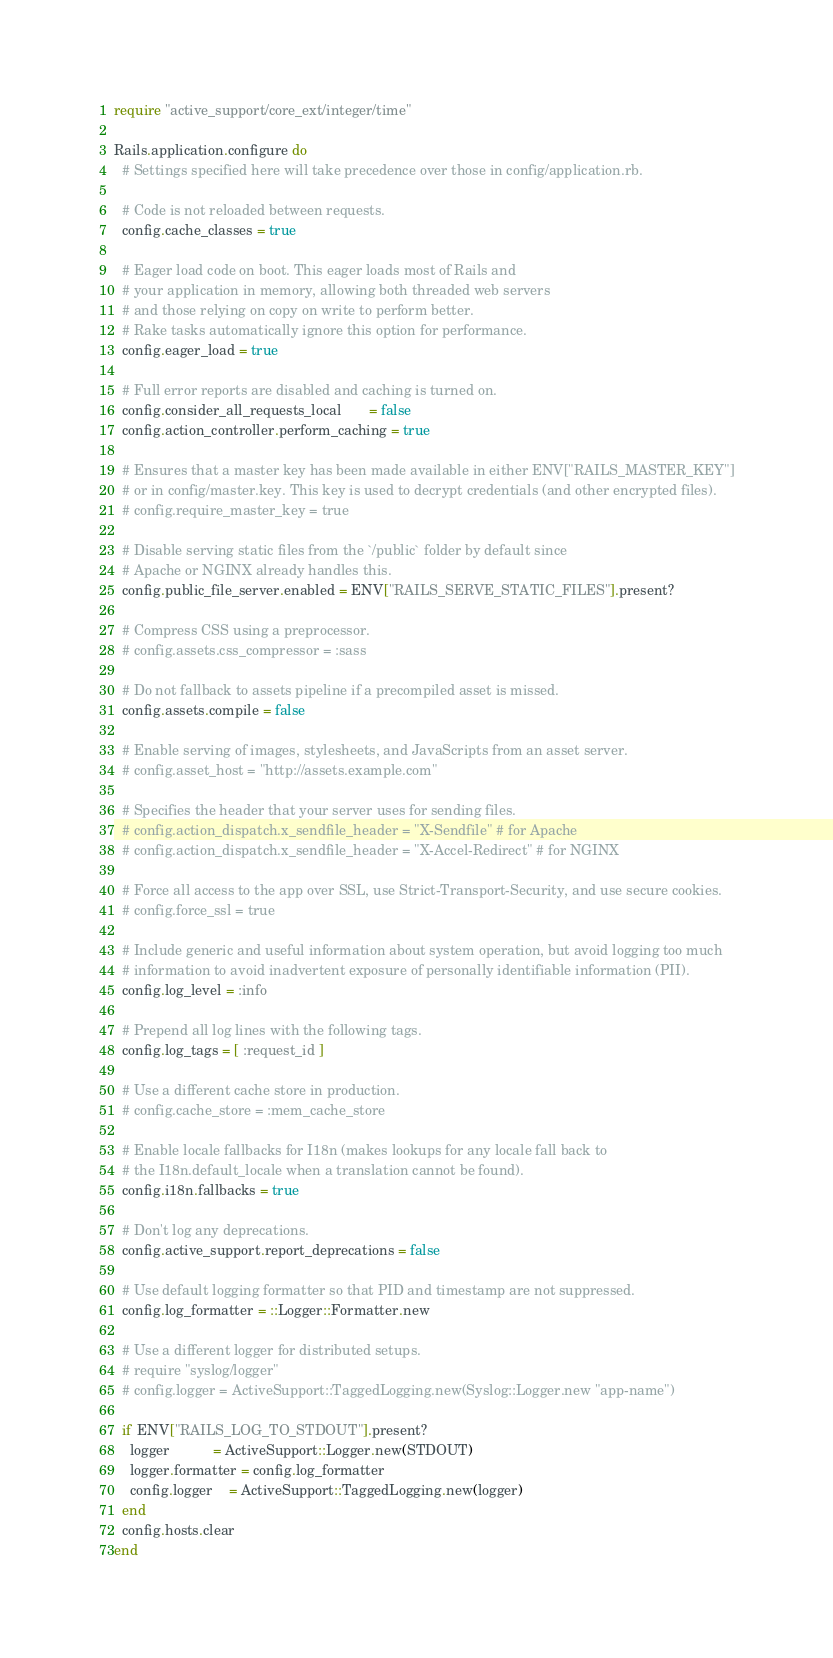<code> <loc_0><loc_0><loc_500><loc_500><_Ruby_>require "active_support/core_ext/integer/time"

Rails.application.configure do
  # Settings specified here will take precedence over those in config/application.rb.

  # Code is not reloaded between requests.
  config.cache_classes = true

  # Eager load code on boot. This eager loads most of Rails and
  # your application in memory, allowing both threaded web servers
  # and those relying on copy on write to perform better.
  # Rake tasks automatically ignore this option for performance.
  config.eager_load = true

  # Full error reports are disabled and caching is turned on.
  config.consider_all_requests_local       = false
  config.action_controller.perform_caching = true

  # Ensures that a master key has been made available in either ENV["RAILS_MASTER_KEY"]
  # or in config/master.key. This key is used to decrypt credentials (and other encrypted files).
  # config.require_master_key = true

  # Disable serving static files from the `/public` folder by default since
  # Apache or NGINX already handles this.
  config.public_file_server.enabled = ENV["RAILS_SERVE_STATIC_FILES"].present?

  # Compress CSS using a preprocessor.
  # config.assets.css_compressor = :sass

  # Do not fallback to assets pipeline if a precompiled asset is missed.
  config.assets.compile = false

  # Enable serving of images, stylesheets, and JavaScripts from an asset server.
  # config.asset_host = "http://assets.example.com"

  # Specifies the header that your server uses for sending files.
  # config.action_dispatch.x_sendfile_header = "X-Sendfile" # for Apache
  # config.action_dispatch.x_sendfile_header = "X-Accel-Redirect" # for NGINX

  # Force all access to the app over SSL, use Strict-Transport-Security, and use secure cookies.
  # config.force_ssl = true

  # Include generic and useful information about system operation, but avoid logging too much
  # information to avoid inadvertent exposure of personally identifiable information (PII).
  config.log_level = :info

  # Prepend all log lines with the following tags.
  config.log_tags = [ :request_id ]

  # Use a different cache store in production.
  # config.cache_store = :mem_cache_store

  # Enable locale fallbacks for I18n (makes lookups for any locale fall back to
  # the I18n.default_locale when a translation cannot be found).
  config.i18n.fallbacks = true

  # Don't log any deprecations.
  config.active_support.report_deprecations = false

  # Use default logging formatter so that PID and timestamp are not suppressed.
  config.log_formatter = ::Logger::Formatter.new

  # Use a different logger for distributed setups.
  # require "syslog/logger"
  # config.logger = ActiveSupport::TaggedLogging.new(Syslog::Logger.new "app-name")

  if ENV["RAILS_LOG_TO_STDOUT"].present?
    logger           = ActiveSupport::Logger.new(STDOUT)
    logger.formatter = config.log_formatter
    config.logger    = ActiveSupport::TaggedLogging.new(logger)
  end
  config.hosts.clear
end
</code> 